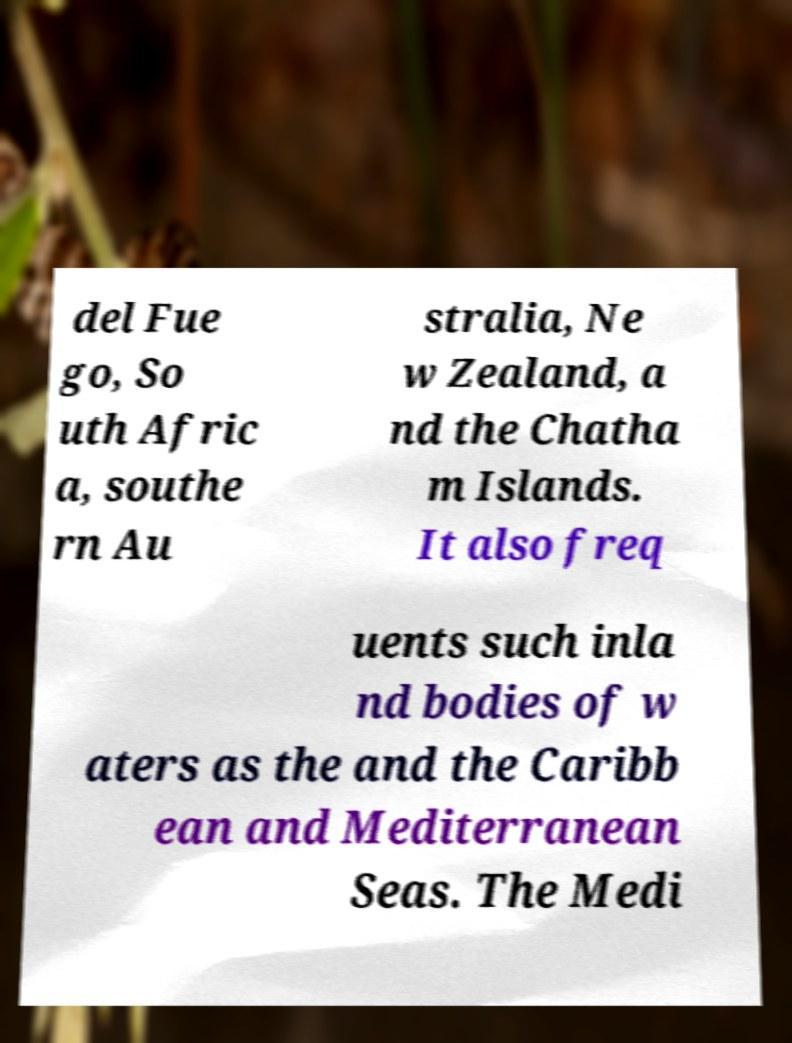I need the written content from this picture converted into text. Can you do that? del Fue go, So uth Afric a, southe rn Au stralia, Ne w Zealand, a nd the Chatha m Islands. It also freq uents such inla nd bodies of w aters as the and the Caribb ean and Mediterranean Seas. The Medi 